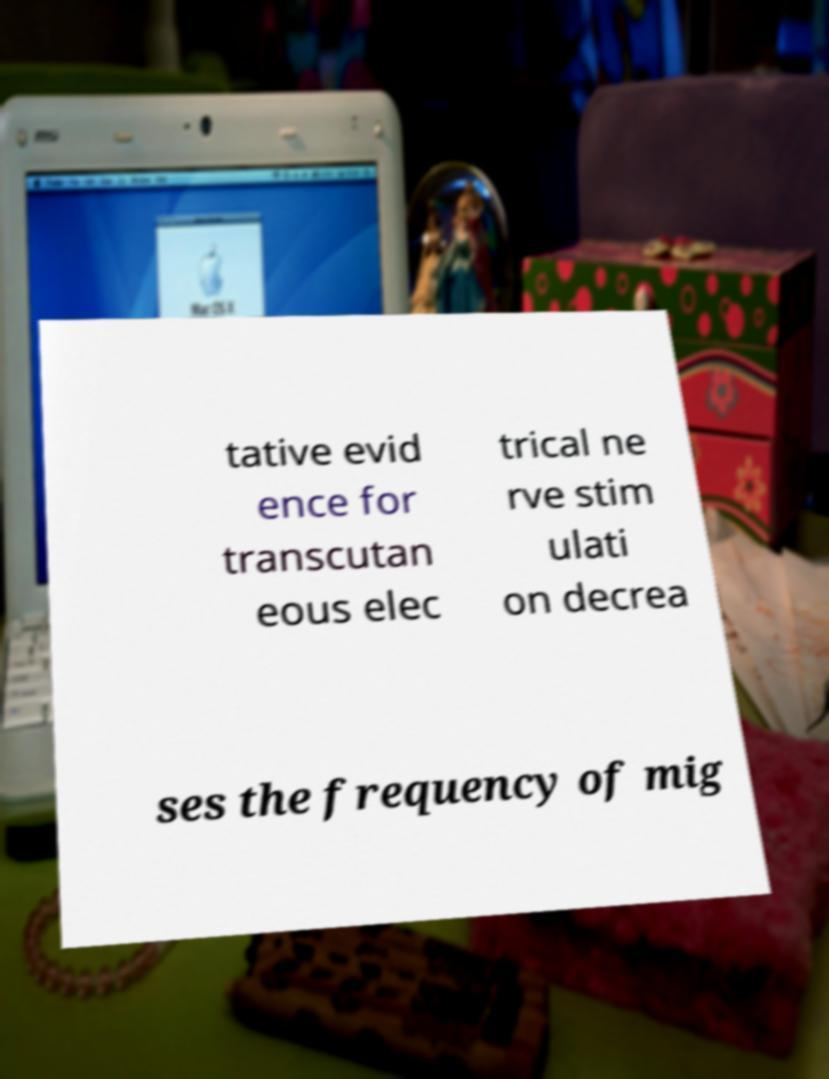What messages or text are displayed in this image? I need them in a readable, typed format. tative evid ence for transcutan eous elec trical ne rve stim ulati on decrea ses the frequency of mig 